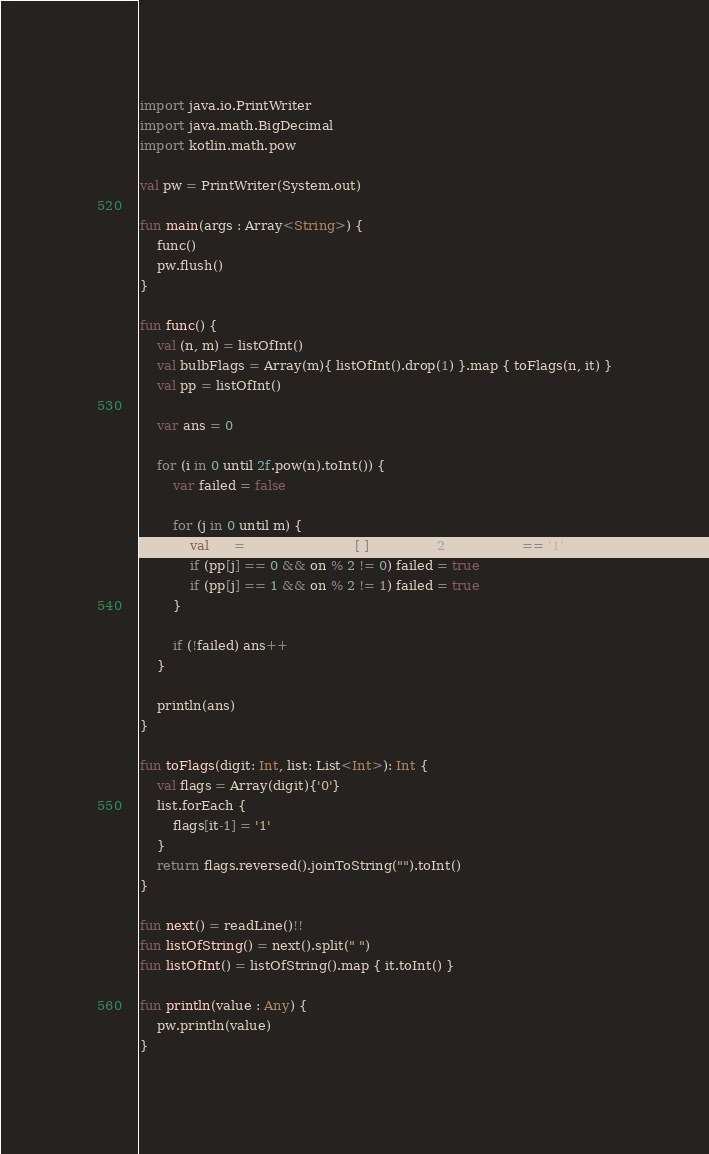<code> <loc_0><loc_0><loc_500><loc_500><_Kotlin_>import java.io.PrintWriter
import java.math.BigDecimal
import kotlin.math.pow

val pw = PrintWriter(System.out)

fun main(args : Array<String>) {
    func()
    pw.flush()
}

fun func() {
    val (n, m) = listOfInt()
    val bulbFlags = Array(m){ listOfInt().drop(1) }.map { toFlags(n, it) }
    val pp = listOfInt()

    var ans = 0

    for (i in 0 until 2f.pow(n).toInt()) {
        var failed = false

        for (j in 0 until m) {
            val on = (i and bulbFlags[j]).toString(2).count { it == '1' }
            if (pp[j] == 0 && on % 2 != 0) failed = true
            if (pp[j] == 1 && on % 2 != 1) failed = true
        }

        if (!failed) ans++
    }

    println(ans)
}

fun toFlags(digit: Int, list: List<Int>): Int {
    val flags = Array(digit){'0'}
    list.forEach {
        flags[it-1] = '1'
    }
    return flags.reversed().joinToString("").toInt()
}

fun next() = readLine()!!
fun listOfString() = next().split(" ")
fun listOfInt() = listOfString().map { it.toInt() }

fun println(value : Any) {
    pw.println(value)
}</code> 